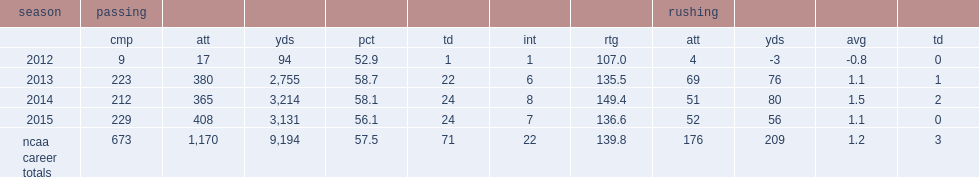How many passing yards did cook finish the season with? 3131.0. How many touchdowns did cook finish the season with? 24.0. 